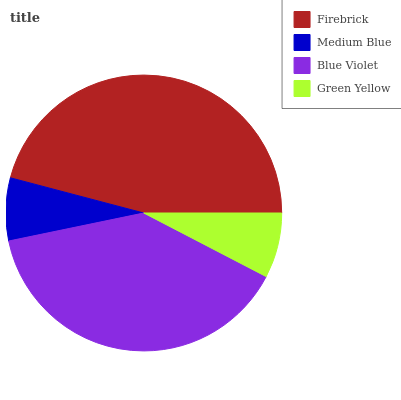Is Medium Blue the minimum?
Answer yes or no. Yes. Is Firebrick the maximum?
Answer yes or no. Yes. Is Blue Violet the minimum?
Answer yes or no. No. Is Blue Violet the maximum?
Answer yes or no. No. Is Blue Violet greater than Medium Blue?
Answer yes or no. Yes. Is Medium Blue less than Blue Violet?
Answer yes or no. Yes. Is Medium Blue greater than Blue Violet?
Answer yes or no. No. Is Blue Violet less than Medium Blue?
Answer yes or no. No. Is Blue Violet the high median?
Answer yes or no. Yes. Is Green Yellow the low median?
Answer yes or no. Yes. Is Green Yellow the high median?
Answer yes or no. No. Is Blue Violet the low median?
Answer yes or no. No. 